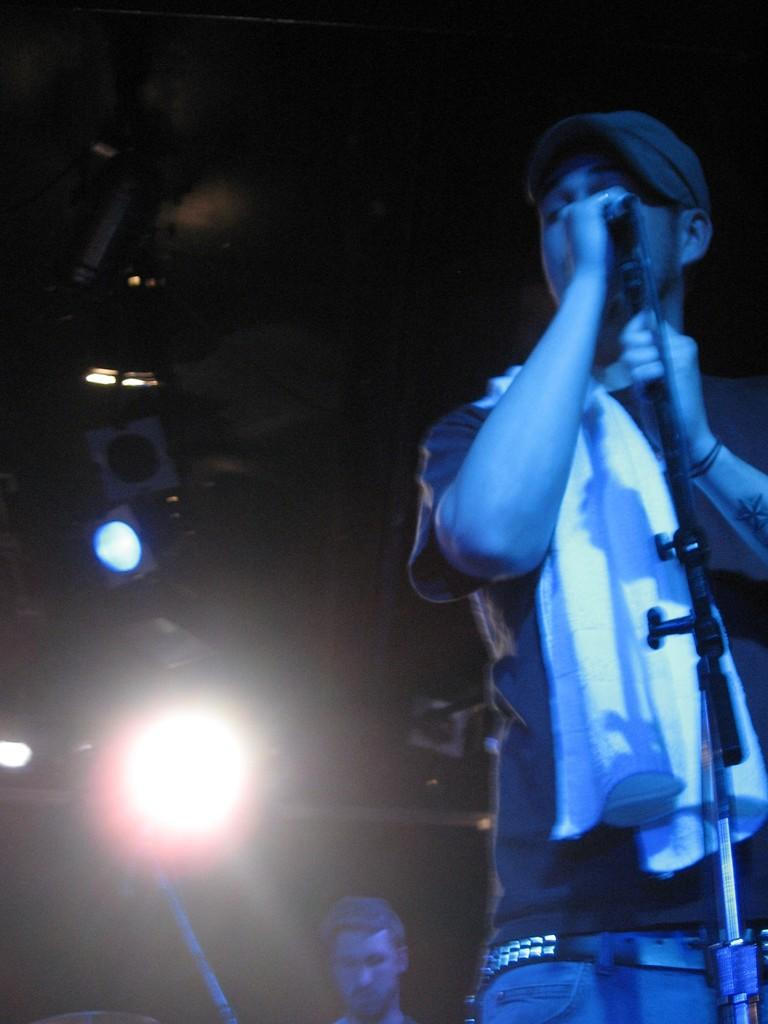What can be seen in the image that is used for holding a microphone? There is a mic stand in the image. How many people are present in the image? There are two men in the image. What can be seen in the image that provides illumination? There are lights in the image. What else is visible in the image besides the mic stand, men, and lights? There are some objects in the image. What is the color of the background in the image? The background of the image is dark. Can you tell me how many times the men are laughing in the image? There is no indication of laughter or any sound in the image, so it's not possible to determine how many times the men are laughing. What type of mass is present in the image? There is no mass visible in the image; the objects mentioned are a mic stand, lights, and some unspecified objects. 